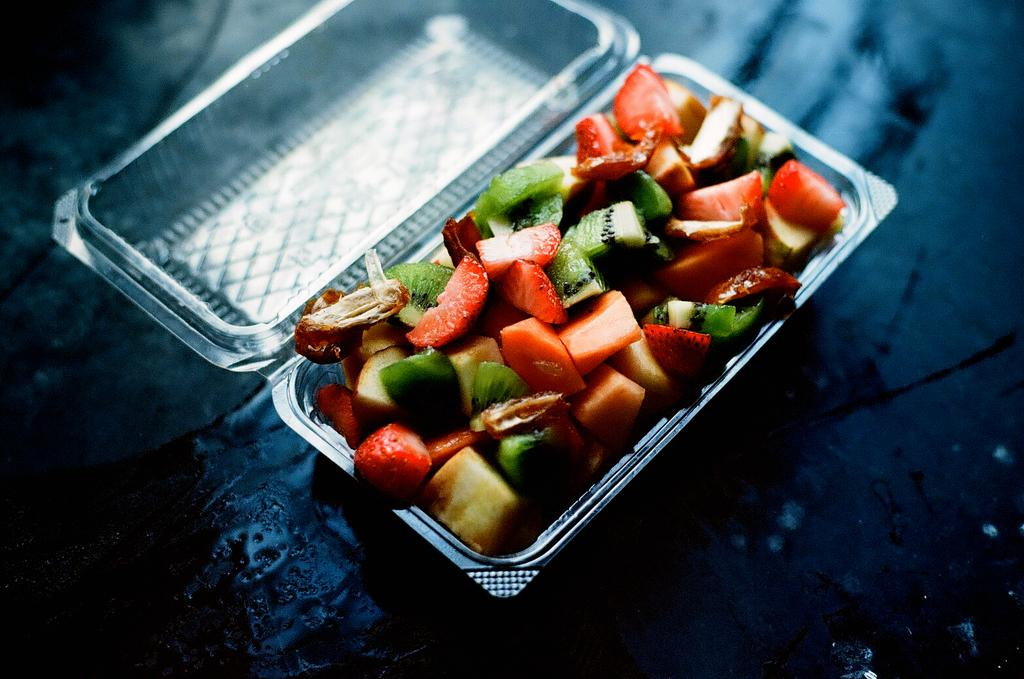What is inside the box that is visible in the image? There is a box containing fruits in the image. What specific fruits can be found in the box? The box contains strawberry slices, kiwi, and papaya. What type of agreement is being signed by the gold statue in the image? There is no gold statue or agreement present in the image. The image only shows a box containing fruits. 